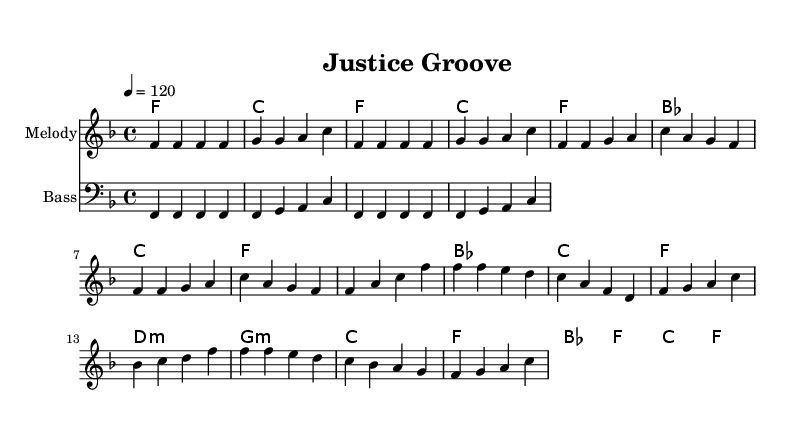What is the key signature of this music? The key signature is indicated by the musical notation at the beginning of the score. In this case, there is one flat (B flat), which indicates that the key is F major.
Answer: F major What is the time signature of this music? The time signature is found next to the key signature at the beginning of the piece. It is written as 4/4, meaning there are four beats in each measure and the quarter note gets one beat.
Answer: 4/4 What is the tempo marking of the piece? The tempo marking is indicated as "4 = 120" in the score, which means that the quarter note is to be played at a tempo of 120 beats per minute.
Answer: 120 How many bars are in the verse section? The verse section is identified in the score by a sequence of measures without blank spaces or breaks. Counting the measures in the verse, there are eight bars in total.
Answer: 8 What type of chords are used in the chorus? The chord progression in the chorus consists of major and minor chords, specifically F major, B flat major, C major, and D minor among others. This combination of major and minor chords is common in disco music, which typically incorporates harmonic variety.
Answer: Major and minor What is the name of the bridge section? The bridge section in this piece is indicated by a change in the melody and harmonies, typically contrasting with the verse and chorus. In the provided music, it is labeled as "Bridge," and this section also maintains a disco rhythm while introducing new melodic material.
Answer: Bridge What rhythm pattern is predominantly used in the bass line? The bass line uses a repetitive rhythm pattern typical of disco music, characterized by a consistent quarter note rhythm followed by a series of ascending notes. This pattern creates a strong groove, which is essential in disco tracks for danceability.
Answer: Repetitive quarter note 